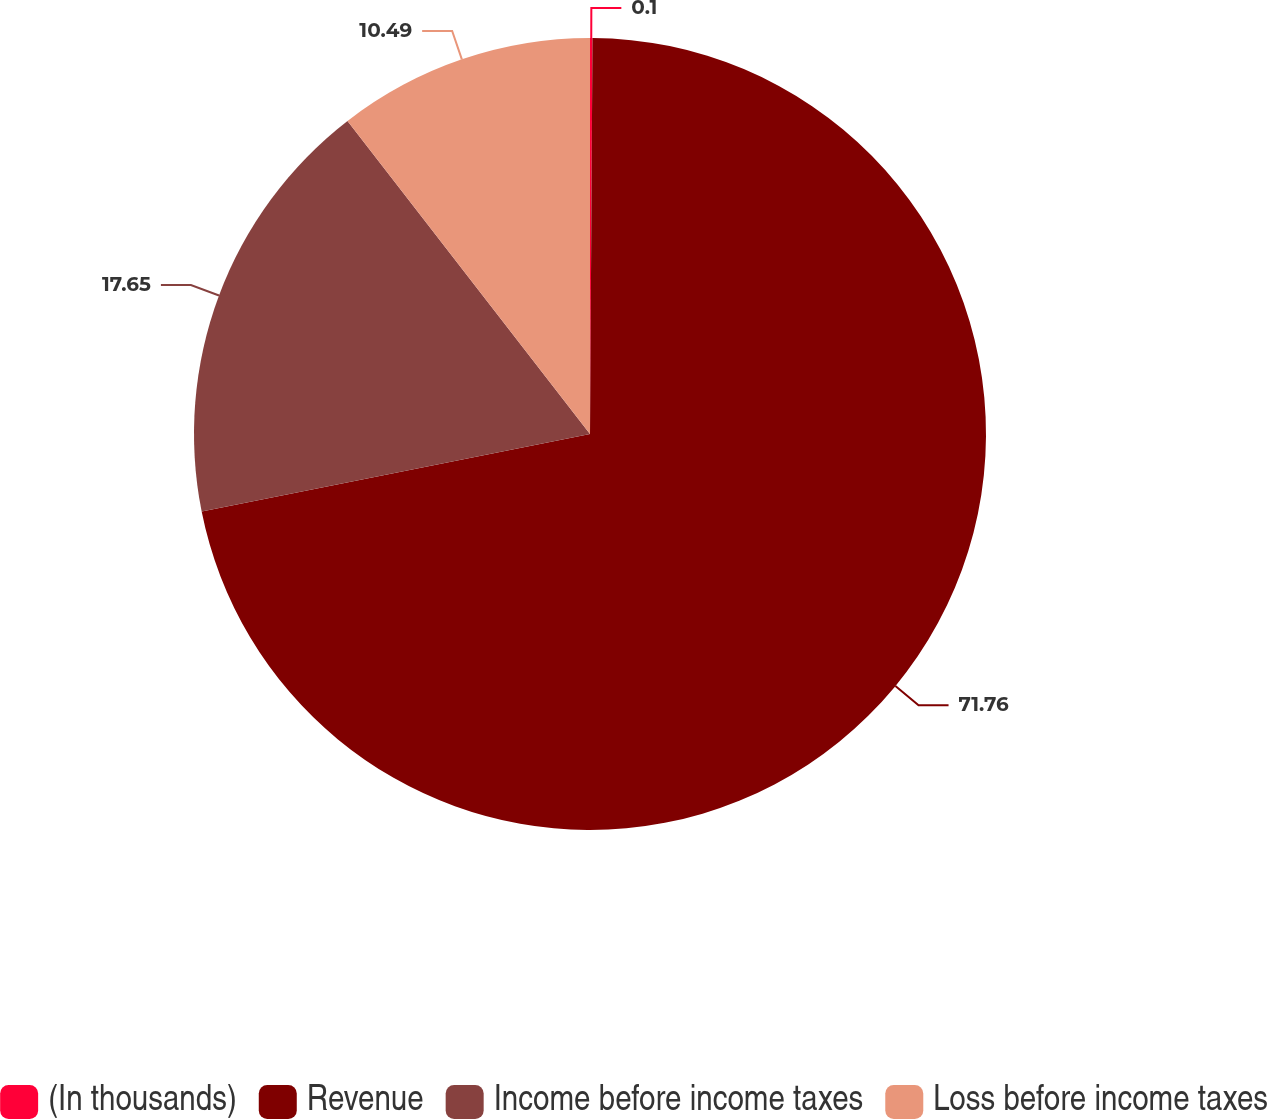Convert chart. <chart><loc_0><loc_0><loc_500><loc_500><pie_chart><fcel>(In thousands)<fcel>Revenue<fcel>Income before income taxes<fcel>Loss before income taxes<nl><fcel>0.1%<fcel>71.77%<fcel>17.65%<fcel>10.49%<nl></chart> 